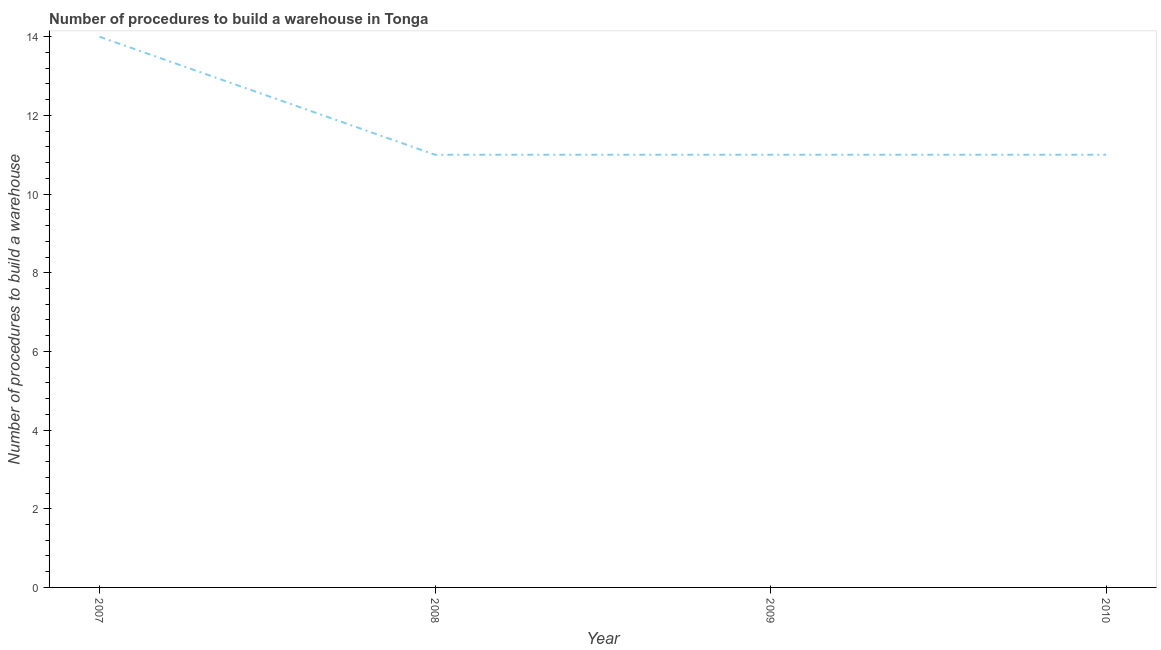What is the number of procedures to build a warehouse in 2008?
Your answer should be very brief. 11. Across all years, what is the maximum number of procedures to build a warehouse?
Offer a very short reply. 14. Across all years, what is the minimum number of procedures to build a warehouse?
Provide a short and direct response. 11. What is the sum of the number of procedures to build a warehouse?
Offer a terse response. 47. What is the difference between the number of procedures to build a warehouse in 2007 and 2010?
Make the answer very short. 3. What is the average number of procedures to build a warehouse per year?
Provide a short and direct response. 11.75. What is the median number of procedures to build a warehouse?
Offer a terse response. 11. In how many years, is the number of procedures to build a warehouse greater than 10.8 ?
Provide a succinct answer. 4. What is the ratio of the number of procedures to build a warehouse in 2007 to that in 2010?
Your answer should be very brief. 1.27. Is the number of procedures to build a warehouse in 2007 less than that in 2009?
Your answer should be compact. No. Is the difference between the number of procedures to build a warehouse in 2007 and 2010 greater than the difference between any two years?
Your answer should be compact. Yes. Is the sum of the number of procedures to build a warehouse in 2007 and 2009 greater than the maximum number of procedures to build a warehouse across all years?
Keep it short and to the point. Yes. What is the difference between the highest and the lowest number of procedures to build a warehouse?
Give a very brief answer. 3. In how many years, is the number of procedures to build a warehouse greater than the average number of procedures to build a warehouse taken over all years?
Make the answer very short. 1. Does the number of procedures to build a warehouse monotonically increase over the years?
Your answer should be very brief. No. How many lines are there?
Give a very brief answer. 1. How many years are there in the graph?
Ensure brevity in your answer.  4. What is the difference between two consecutive major ticks on the Y-axis?
Provide a succinct answer. 2. Does the graph contain any zero values?
Offer a very short reply. No. What is the title of the graph?
Your response must be concise. Number of procedures to build a warehouse in Tonga. What is the label or title of the Y-axis?
Offer a terse response. Number of procedures to build a warehouse. What is the Number of procedures to build a warehouse in 2009?
Your answer should be very brief. 11. What is the difference between the Number of procedures to build a warehouse in 2007 and 2008?
Your response must be concise. 3. What is the difference between the Number of procedures to build a warehouse in 2007 and 2010?
Offer a very short reply. 3. What is the difference between the Number of procedures to build a warehouse in 2008 and 2009?
Offer a terse response. 0. What is the difference between the Number of procedures to build a warehouse in 2008 and 2010?
Provide a succinct answer. 0. What is the difference between the Number of procedures to build a warehouse in 2009 and 2010?
Your answer should be very brief. 0. What is the ratio of the Number of procedures to build a warehouse in 2007 to that in 2008?
Offer a very short reply. 1.27. What is the ratio of the Number of procedures to build a warehouse in 2007 to that in 2009?
Keep it short and to the point. 1.27. What is the ratio of the Number of procedures to build a warehouse in 2007 to that in 2010?
Give a very brief answer. 1.27. What is the ratio of the Number of procedures to build a warehouse in 2008 to that in 2009?
Offer a very short reply. 1. 